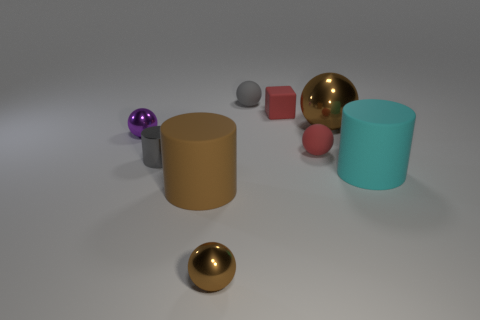Subtract all gray balls. How many balls are left? 4 Subtract all gray balls. How many balls are left? 4 Subtract all cyan balls. Subtract all purple cubes. How many balls are left? 5 Add 1 large cyan rubber cylinders. How many objects exist? 10 Subtract all cylinders. How many objects are left? 6 Add 2 purple metal balls. How many purple metal balls exist? 3 Subtract 0 green spheres. How many objects are left? 9 Subtract all tiny brown rubber things. Subtract all big cyan things. How many objects are left? 8 Add 8 red rubber objects. How many red rubber objects are left? 10 